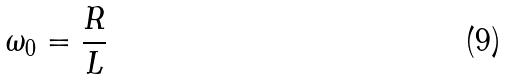Convert formula to latex. <formula><loc_0><loc_0><loc_500><loc_500>\omega _ { 0 } = \frac { R } { L }</formula> 